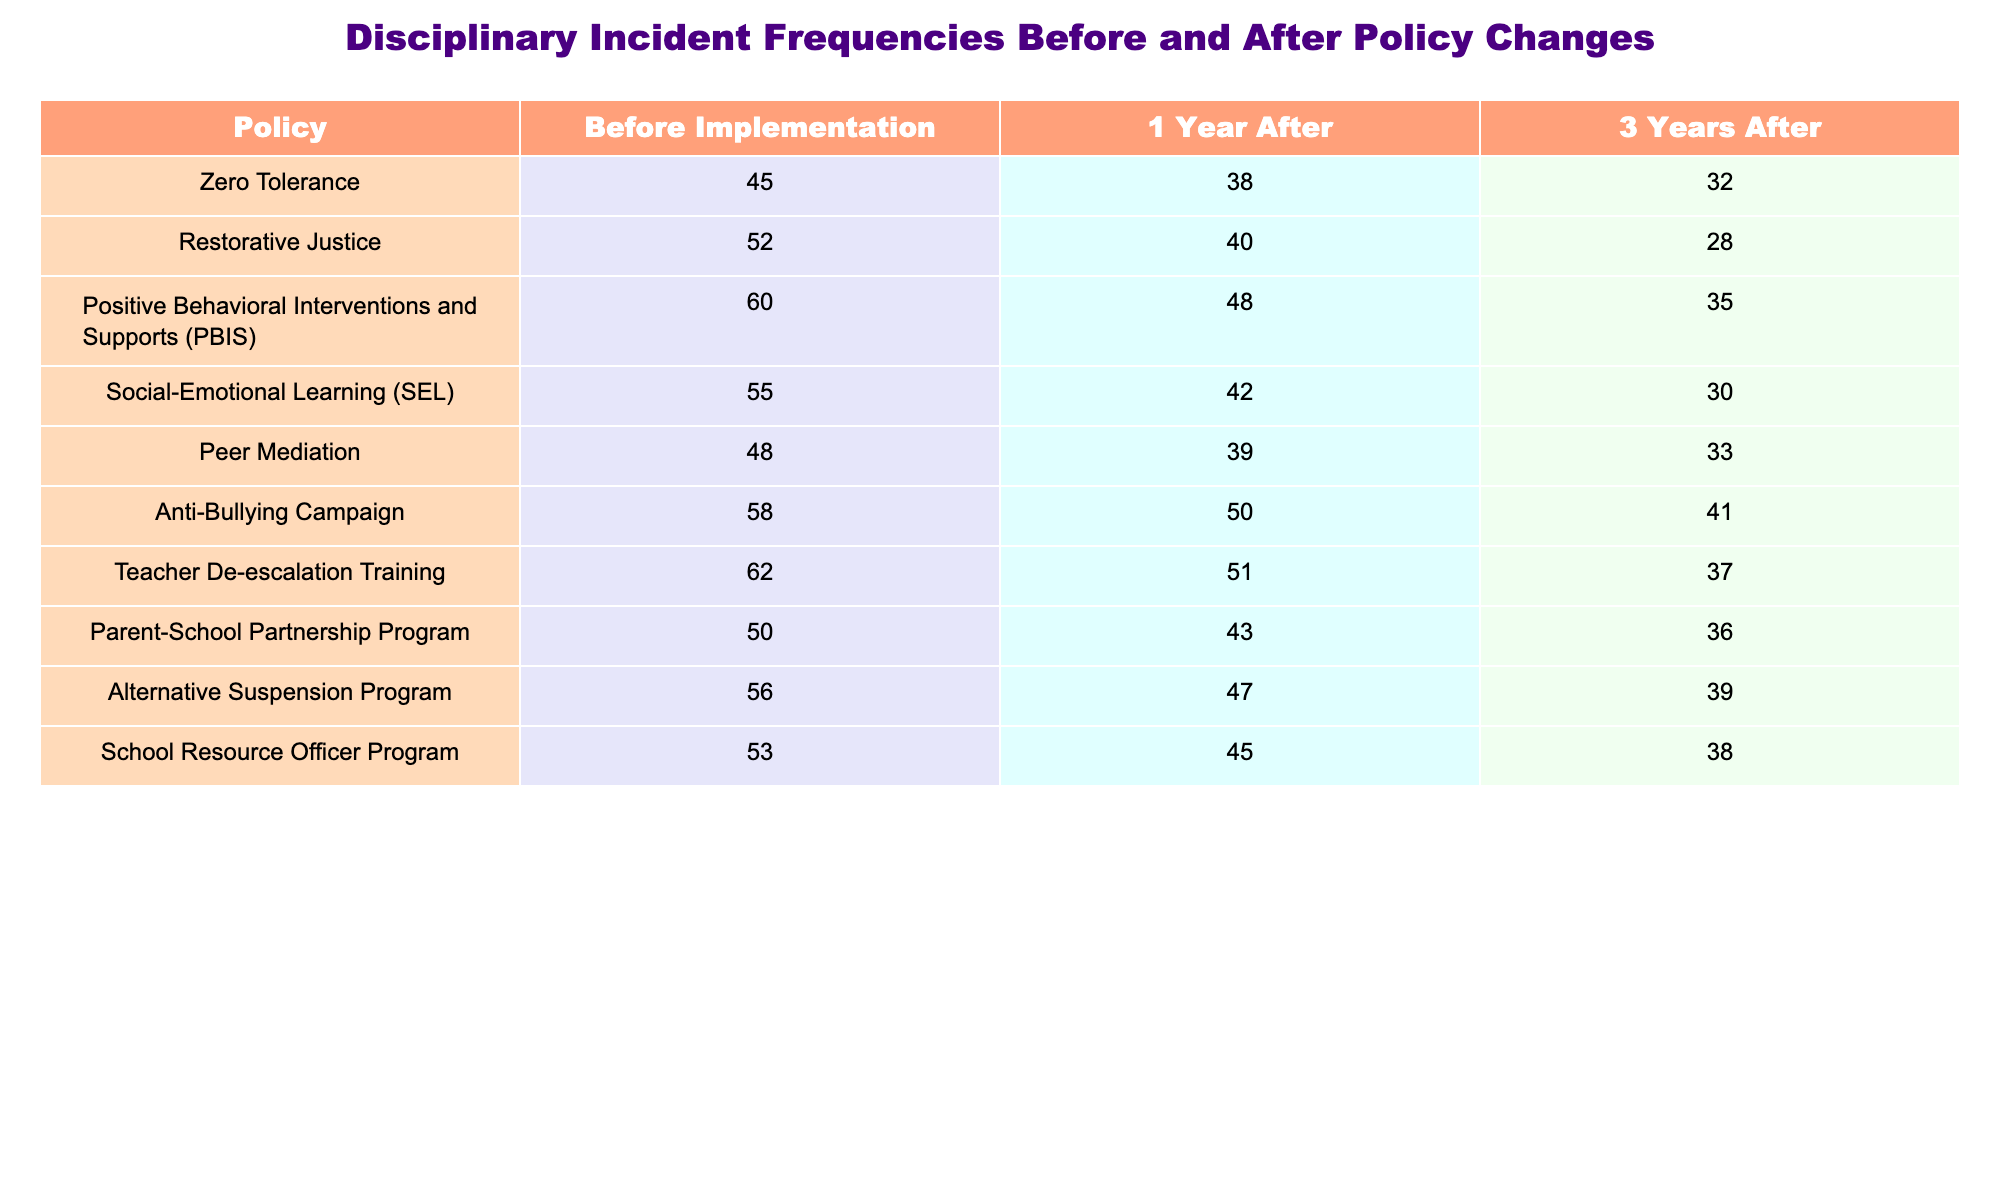What was the frequency of disciplinary incidents for the Zero Tolerance policy before implementation? The table shows that the frequency of disciplinary incidents for the Zero Tolerance policy before implementation was 45.
Answer: 45 What is the incident frequency for the Anti-Bullying Campaign three years after implementation? According to the table, three years after implementing the Anti-Bullying Campaign, the incident frequency was 41.
Answer: 41 Which policy had the highest frequency of incidents one year after implementation? The table indicates that the Teacher De-escalation Training policy had the highest frequency of incidents one year after implementation at 51.
Answer: 51 What is the percentage decrease in disciplinary incidents for the Peer Mediation policy from before implementation to three years after? Before implementation, the frequency was 48, and three years later it was 33. The decrease is 48 - 33 = 15. To find the percentage decrease: (15 / 48) * 100 = 31.25%.
Answer: 31.25% Was there a decrease in disciplinary incidents for all policies one year after implementation compared to before? Assessing the table, all listed policies show a decrease in incident frequency one year after implementation when compared to before.
Answer: Yes Which policy showed the smallest decline in disciplinary incidents from before implementation to one year after? From the table, the policy with the smallest decline within one year is the Anti-Bullying Campaign, which decreased from 58 to 50, a drop of 8 incidents.
Answer: Anti-Bullying Campaign What is the average frequency of disciplinary incidents across all policies three years after implementation? Summing the frequencies for all policies three years after gives (32 + 28 + 35 + 30 + 33 + 41 + 37 + 36 + 39 + 38) = 339. Dividing by the number of policies (10) provides an average frequency of 33.9.
Answer: 33.9 How many total incidents were reported after three years across all policies? Adding the incident frequencies for all policies three years after implementation: 32 + 28 + 35 + 30 + 33 + 41 + 37 + 36 + 39 + 38 = 339.
Answer: 339 Did the implementation of the Restorative Justice policy result in a higher frequency of incidents after one year compared to before? The frequency before was 52, and after one year it decreased to 40, thus confirming that incidents were higher before implementation.
Answer: No Which policy maintained the lowest frequency of incidents over all three periods? Analyzing the table, the policy with the lowest frequency over the three periods is the Restorative Justice policy, which had an incident frequency of 28 after three years, noting this as the lowest recorded.
Answer: Restorative Justice policy 